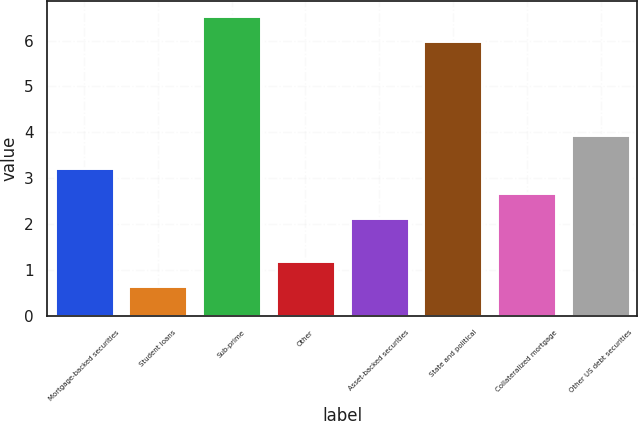<chart> <loc_0><loc_0><loc_500><loc_500><bar_chart><fcel>Mortgage-backed securities<fcel>Student loans<fcel>Sub-prime<fcel>Other<fcel>Asset-backed securities<fcel>State and political<fcel>Collateralized mortgage<fcel>Other US debt securities<nl><fcel>3.23<fcel>0.66<fcel>6.53<fcel>1.21<fcel>2.13<fcel>5.98<fcel>2.68<fcel>3.94<nl></chart> 